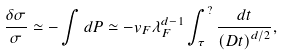Convert formula to latex. <formula><loc_0><loc_0><loc_500><loc_500>\frac { \delta \sigma } { \sigma } \simeq - \int d P \simeq - v _ { F } \lambda _ { F } ^ { d - 1 } \int _ { \tau } ^ { ? } \frac { d t } { \left ( D t \right ) ^ { d / 2 } } ,</formula> 